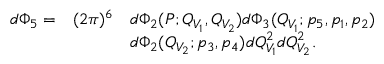Convert formula to latex. <formula><loc_0><loc_0><loc_500><loc_500>\begin{array} { l l l } { { d \Phi _ { 5 } = } } & { { ( 2 \pi ) ^ { 6 } } } & { { d \Phi _ { 2 } ( P ; Q _ { V _ { 1 } } , Q _ { V _ { 2 } } ) d \Phi _ { 3 } ( Q _ { V _ { 1 } } ; p _ { 5 } , p _ { 1 } , p _ { 2 } ) } } & { { d \Phi _ { 2 } ( Q _ { V _ { 2 } } ; p _ { 3 } , p _ { 4 } ) d Q _ { V _ { 1 } } ^ { 2 } d Q _ { V _ { 2 } } ^ { 2 } . } } \end{array}</formula> 